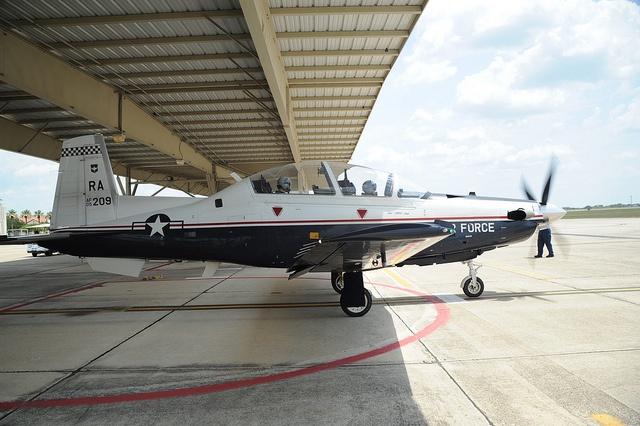Describe the objects in this image and their specific colors. I can see airplane in black, darkgray, white, and gray tones, people in black, navy, darkgray, and lightgray tones, people in black and gray tones, and people in black and gray tones in this image. 